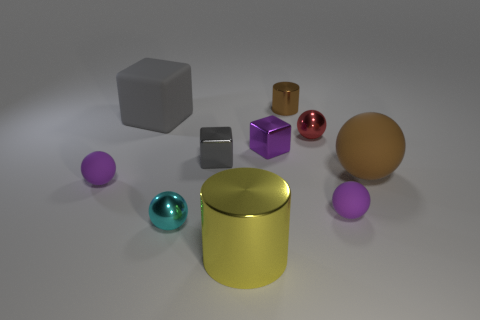Can you tell which material each object might be made of? The different sheens suggest a variety of materials. The reflective metal appearance of the gold, silver, and red objects indicate a metallic makeup. The matte finish of the grey cube suggests a ceramic or plastic material. The purple and cyan objects, with their lighter sheen, could be made of anodized aluminum or painted metal. 